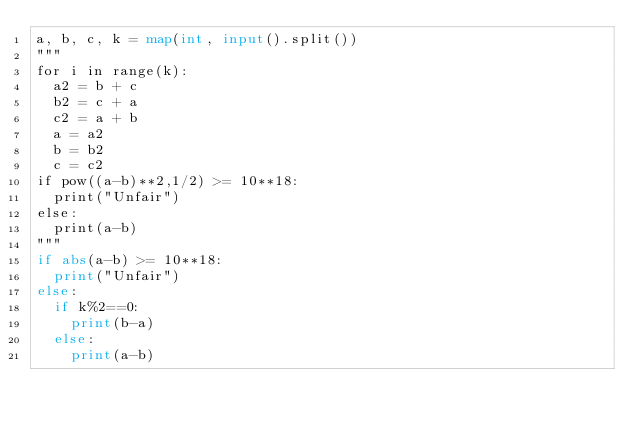Convert code to text. <code><loc_0><loc_0><loc_500><loc_500><_Python_>a, b, c, k = map(int, input().split())
"""
for i in range(k):
  a2 = b + c
  b2 = c + a
  c2 = a + b
  a = a2
  b = b2
  c = c2
if pow((a-b)**2,1/2) >= 10**18:
  print("Unfair")
else:
  print(a-b)
"""
if abs(a-b) >= 10**18:
  print("Unfair")
else:
  if k%2==0:
    print(b-a)
  else:
    print(a-b)</code> 